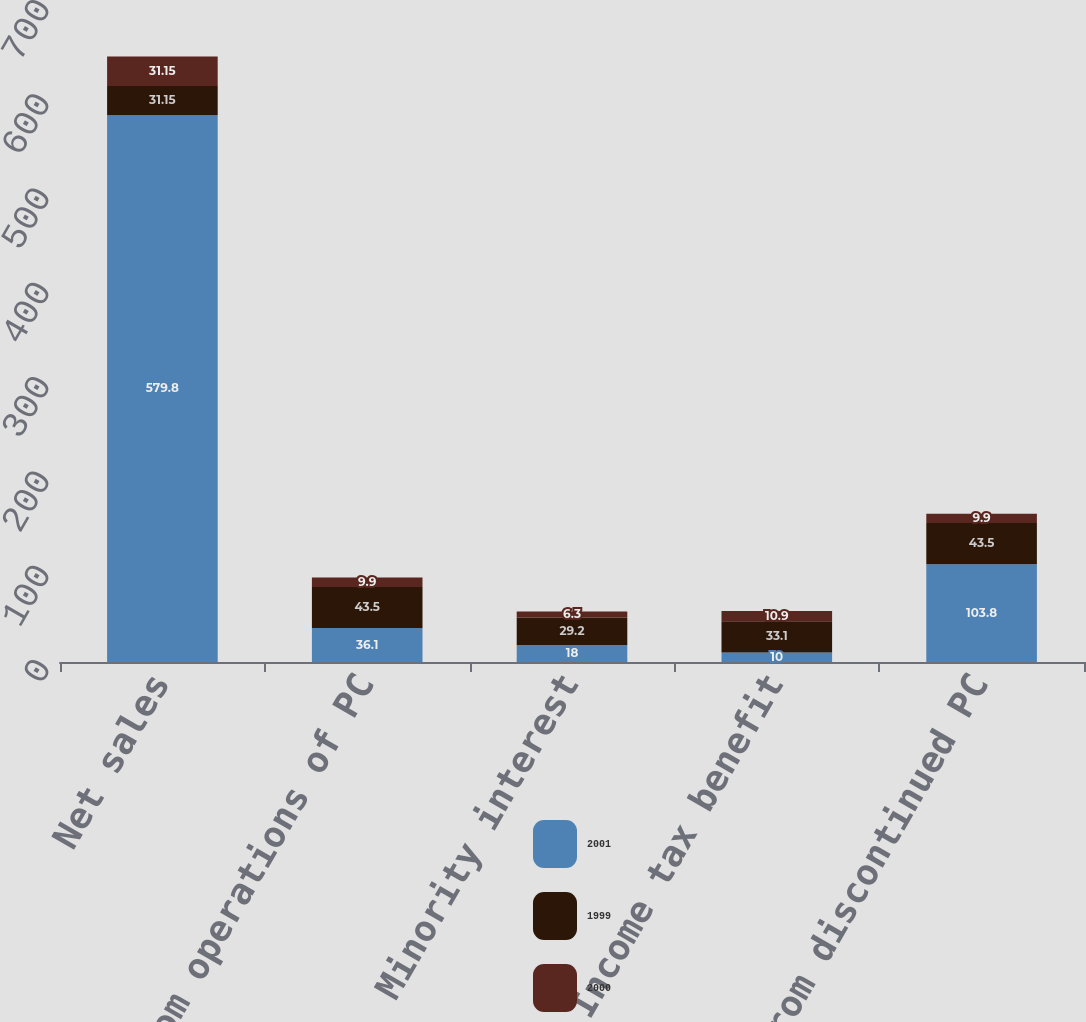Convert chart. <chart><loc_0><loc_0><loc_500><loc_500><stacked_bar_chart><ecel><fcel>Net sales<fcel>Loss from operations of PC<fcel>Minority interest<fcel>Income tax benefit<fcel>Loss from discontinued PC<nl><fcel>2001<fcel>579.8<fcel>36.1<fcel>18<fcel>10<fcel>103.8<nl><fcel>1999<fcel>31.15<fcel>43.5<fcel>29.2<fcel>33.1<fcel>43.5<nl><fcel>2000<fcel>31.15<fcel>9.9<fcel>6.3<fcel>10.9<fcel>9.9<nl></chart> 